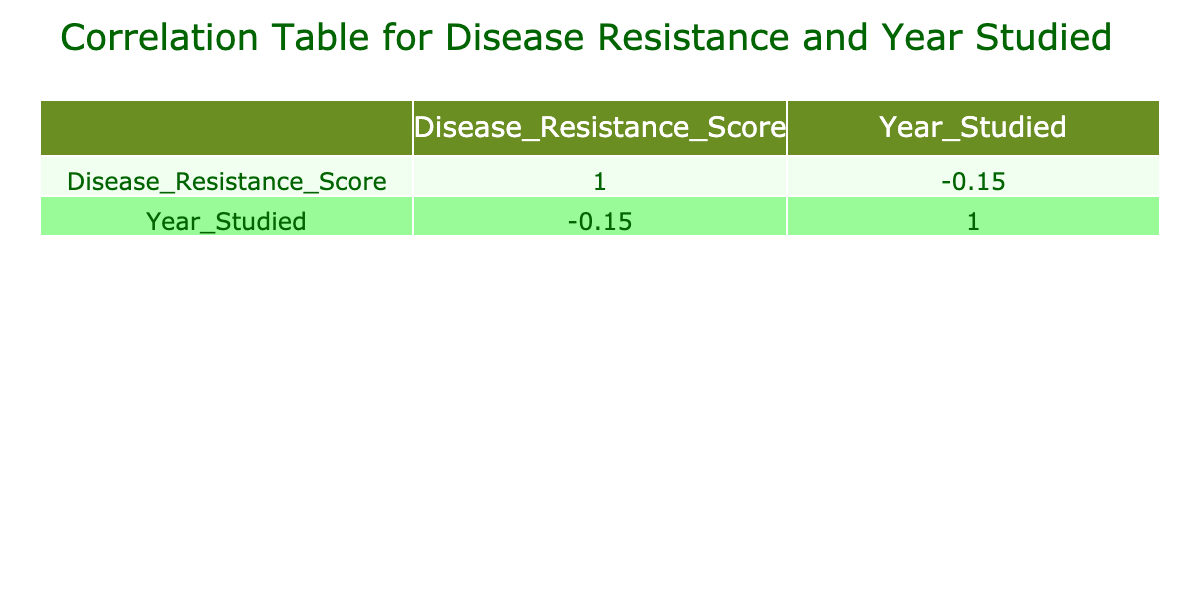What is the Disease Resistance Score for RM2345? The table shows the entry for RM2345 under the Disease Resistance Score column; it directly lists the score next to this genetic marker. The score is 95.
Answer: 95 Which Plant Type has the highest Disease Resistance Score? By examining the Disease Resistance Score column, RM8910 for Peppers has the highest score listed at 97, making it the plant type with the highest resistance score.
Answer: Peppers What is the average Disease Resistance Score for the crops studied in 2021? The entries for 2021 are RM1234 (85), RM2345 (95), and RM7890 (92). Adding them gives 85 + 95 + 92 = 272. There are three entries, so the average score is 272/3 = 90.67.
Answer: 90.67 Is there a genetic marker that shows a Disease Resistance Score of 75 or lower? Looking through the Disease Resistance Score column, RM4567 associated with Barley has a score of 75, confirming that such a genetic marker exists.
Answer: Yes What is the difference in Disease Resistance Score between the highest scoring plant and the lowest scoring plant in 2020? The highest score in 2020 is 90 for RM5678 (Soybean), and the lowest score is 82 for RM1237 (Carrot). The difference is 90 - 82 = 8.
Answer: 8 Which year had the most studied crops in the dataset, based on distinct entries? To find out the year with the most entries, we can count the occurrences: 2020 has 3 entries (RM5678, RM3456, RM1237), 2021 has 3 entries (RM1234, RM2345, RM7890), 2022 has 2 entries (RM9101, RM4567), while 2023 has 2 entries (RM6789, RM8910). Since 2020 and 2021 have the most entries with 3, they are tied.
Answer: 2020 and 2021 What is the year studied associated with the marker RM6789? The table lists RM6789 along with its corresponding year studied, which is 2023. The data provides this information clearly.
Answer: 2023 What is the sum of the Disease Resistance Scores for all the crops studied in 2022? Looking at the crops for 2022, we find RM9101 (78) and RM4567 (75). Adding these gives 78 + 75 = 153, which is the total for that year.
Answer: 153 What is the Disease Resistance Score difference between Tomato and Wheat? Tomato has a score of 80 (RM6789) while Wheat has a score of 78 (RM9101). The difference is calculated as 80 - 78 = 2.
Answer: 2 